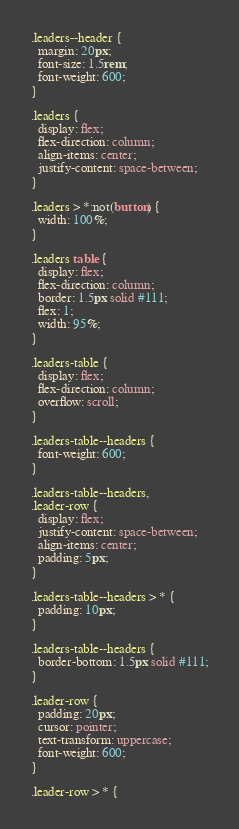<code> <loc_0><loc_0><loc_500><loc_500><_CSS_>.leaders--header {
  margin: 20px;
  font-size: 1.5rem;
  font-weight: 600;
}

.leaders {
  display: flex;
  flex-direction: column;
  align-items: center;
  justify-content: space-between;
}

.leaders > *:not(button) {
  width: 100%;
}

.leaders table {
  display: flex;
  flex-direction: column;
  border: 1.5px solid #111;
  flex: 1;
  width: 95%;
}

.leaders-table {
  display: flex;
  flex-direction: column;
  overflow: scroll;
}

.leaders-table--headers {
  font-weight: 600;
}

.leaders-table--headers,
.leader-row {
  display: flex;
  justify-content: space-between;
  align-items: center;
  padding: 5px;
}

.leaders-table--headers > * {
  padding: 10px;
}

.leaders-table--headers {
  border-bottom: 1.5px solid #111;
}

.leader-row {
  padding: 20px;
  cursor: pointer;
  text-transform: uppercase;
  font-weight: 600;
}

.leader-row > * {</code> 